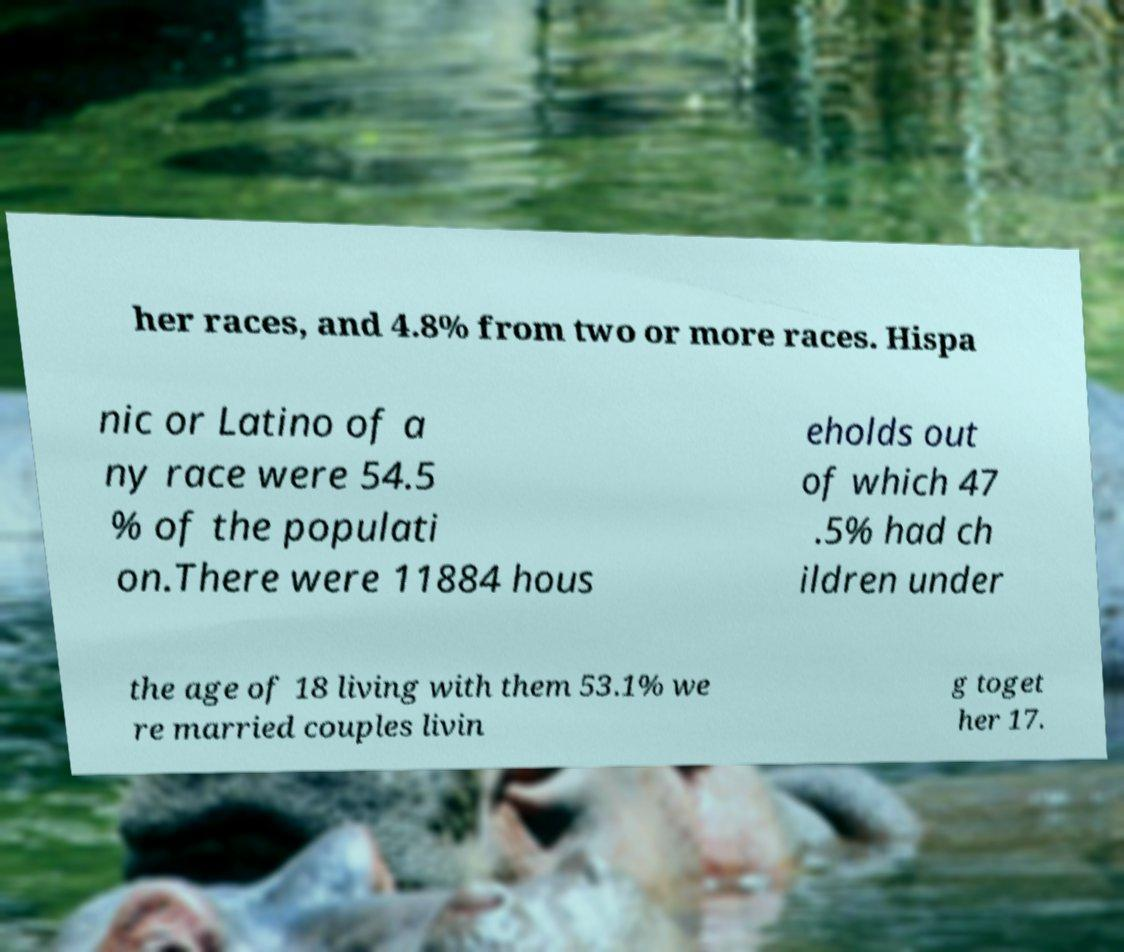What messages or text are displayed in this image? I need them in a readable, typed format. her races, and 4.8% from two or more races. Hispa nic or Latino of a ny race were 54.5 % of the populati on.There were 11884 hous eholds out of which 47 .5% had ch ildren under the age of 18 living with them 53.1% we re married couples livin g toget her 17. 